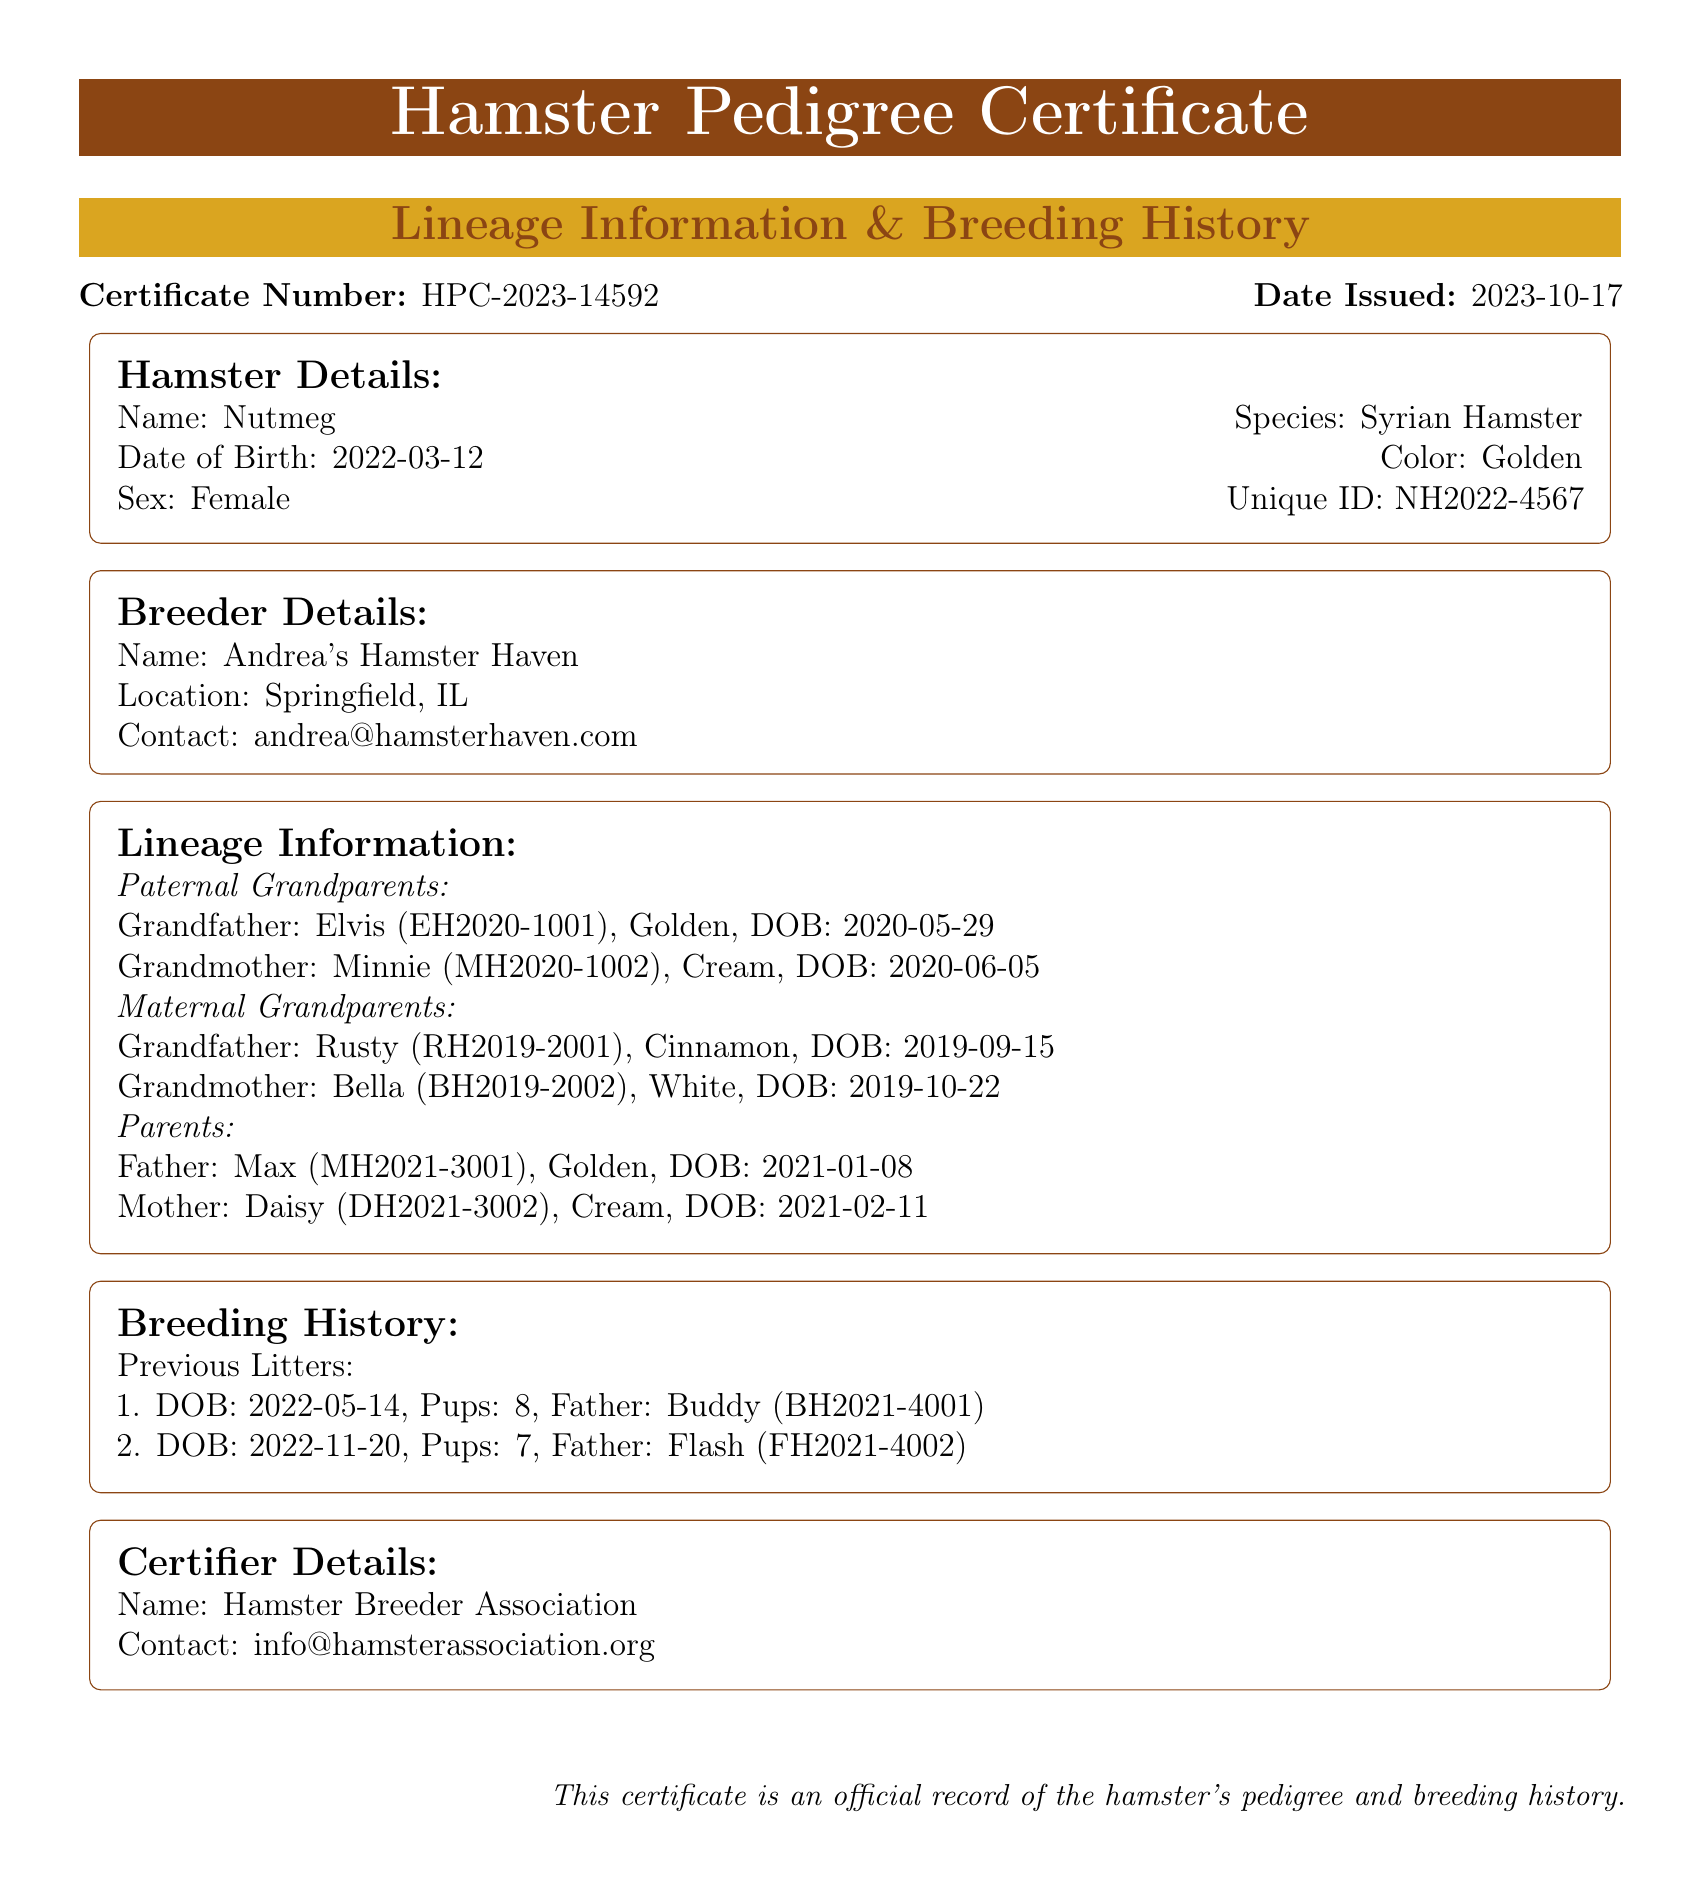What is the certificate number? The certificate number is displayed clearly in the document, which is HPC-2023-14592.
Answer: HPC-2023-14592 What is the date of birth of Nutmeg? Nutmeg's date of birth is presented in the hamster details section as 2022-03-12.
Answer: 2022-03-12 Who is Nutmeg's father? The father of Nutmeg can be found in the lineage information, which lists him as Max.
Answer: Max How many pups were in the first litter? The breeding history section states that the first litter had 8 pups.
Answer: 8 What color is Nutmeg? The color of Nutmeg is mentioned in her details as Golden.
Answer: Golden What is the name of Nutmeg's maternal grandmother? The maternal grandmother of Nutmeg is listed in the lineage information as Bella.
Answer: Bella Where is the breeder located? The location of the breeder is mentioned in the breeder details as Springfield, IL.
Answer: Springfield, IL Who graded the pedigree certificate? The certifier details section identifies the organization as Hamster Breeder Association.
Answer: Hamster Breeder Association When was Nutmeg's last litter born? From the breeding history, the last litter's date of birth is 2022-11-20.
Answer: 2022-11-20 